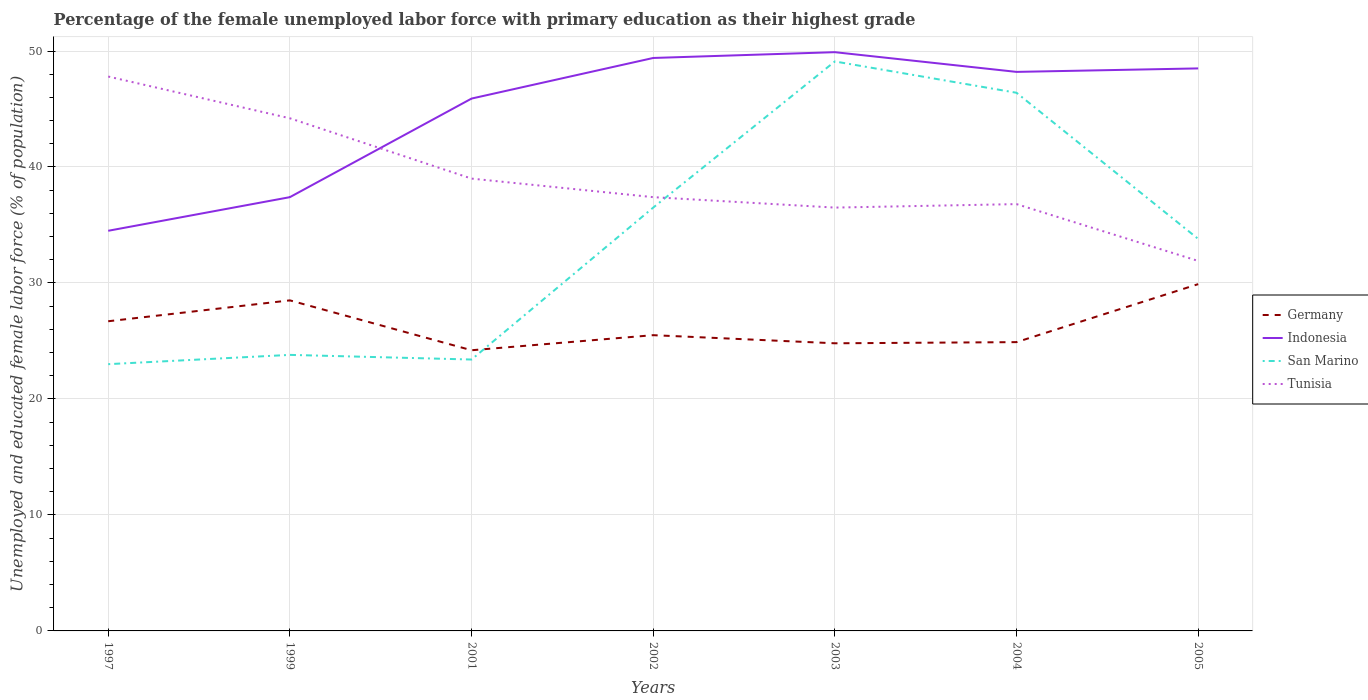How many different coloured lines are there?
Give a very brief answer. 4. Across all years, what is the maximum percentage of the unemployed female labor force with primary education in Indonesia?
Offer a terse response. 34.5. What is the total percentage of the unemployed female labor force with primary education in San Marino in the graph?
Offer a very short reply. -25.3. What is the difference between the highest and the second highest percentage of the unemployed female labor force with primary education in San Marino?
Your response must be concise. 26.1. What is the difference between the highest and the lowest percentage of the unemployed female labor force with primary education in Germany?
Offer a very short reply. 3. Is the percentage of the unemployed female labor force with primary education in Indonesia strictly greater than the percentage of the unemployed female labor force with primary education in Tunisia over the years?
Give a very brief answer. No. Does the graph contain any zero values?
Keep it short and to the point. No. Does the graph contain grids?
Keep it short and to the point. Yes. How many legend labels are there?
Ensure brevity in your answer.  4. How are the legend labels stacked?
Offer a terse response. Vertical. What is the title of the graph?
Offer a terse response. Percentage of the female unemployed labor force with primary education as their highest grade. Does "Niger" appear as one of the legend labels in the graph?
Provide a succinct answer. No. What is the label or title of the X-axis?
Make the answer very short. Years. What is the label or title of the Y-axis?
Your answer should be very brief. Unemployed and educated female labor force (% of population). What is the Unemployed and educated female labor force (% of population) of Germany in 1997?
Keep it short and to the point. 26.7. What is the Unemployed and educated female labor force (% of population) of Indonesia in 1997?
Ensure brevity in your answer.  34.5. What is the Unemployed and educated female labor force (% of population) of San Marino in 1997?
Your answer should be compact. 23. What is the Unemployed and educated female labor force (% of population) of Tunisia in 1997?
Provide a succinct answer. 47.8. What is the Unemployed and educated female labor force (% of population) of Indonesia in 1999?
Provide a short and direct response. 37.4. What is the Unemployed and educated female labor force (% of population) in San Marino in 1999?
Offer a terse response. 23.8. What is the Unemployed and educated female labor force (% of population) in Tunisia in 1999?
Your answer should be very brief. 44.2. What is the Unemployed and educated female labor force (% of population) in Germany in 2001?
Provide a short and direct response. 24.2. What is the Unemployed and educated female labor force (% of population) in Indonesia in 2001?
Give a very brief answer. 45.9. What is the Unemployed and educated female labor force (% of population) in San Marino in 2001?
Give a very brief answer. 23.4. What is the Unemployed and educated female labor force (% of population) of Indonesia in 2002?
Ensure brevity in your answer.  49.4. What is the Unemployed and educated female labor force (% of population) of San Marino in 2002?
Offer a terse response. 36.5. What is the Unemployed and educated female labor force (% of population) in Tunisia in 2002?
Provide a short and direct response. 37.4. What is the Unemployed and educated female labor force (% of population) of Germany in 2003?
Provide a succinct answer. 24.8. What is the Unemployed and educated female labor force (% of population) in Indonesia in 2003?
Offer a terse response. 49.9. What is the Unemployed and educated female labor force (% of population) of San Marino in 2003?
Your response must be concise. 49.1. What is the Unemployed and educated female labor force (% of population) in Tunisia in 2003?
Your response must be concise. 36.5. What is the Unemployed and educated female labor force (% of population) in Germany in 2004?
Provide a short and direct response. 24.9. What is the Unemployed and educated female labor force (% of population) in Indonesia in 2004?
Provide a succinct answer. 48.2. What is the Unemployed and educated female labor force (% of population) in San Marino in 2004?
Keep it short and to the point. 46.4. What is the Unemployed and educated female labor force (% of population) of Tunisia in 2004?
Ensure brevity in your answer.  36.8. What is the Unemployed and educated female labor force (% of population) in Germany in 2005?
Keep it short and to the point. 29.9. What is the Unemployed and educated female labor force (% of population) of Indonesia in 2005?
Offer a very short reply. 48.5. What is the Unemployed and educated female labor force (% of population) in San Marino in 2005?
Provide a succinct answer. 33.8. What is the Unemployed and educated female labor force (% of population) of Tunisia in 2005?
Your response must be concise. 31.9. Across all years, what is the maximum Unemployed and educated female labor force (% of population) in Germany?
Ensure brevity in your answer.  29.9. Across all years, what is the maximum Unemployed and educated female labor force (% of population) in Indonesia?
Your answer should be very brief. 49.9. Across all years, what is the maximum Unemployed and educated female labor force (% of population) of San Marino?
Give a very brief answer. 49.1. Across all years, what is the maximum Unemployed and educated female labor force (% of population) of Tunisia?
Ensure brevity in your answer.  47.8. Across all years, what is the minimum Unemployed and educated female labor force (% of population) in Germany?
Make the answer very short. 24.2. Across all years, what is the minimum Unemployed and educated female labor force (% of population) in Indonesia?
Ensure brevity in your answer.  34.5. Across all years, what is the minimum Unemployed and educated female labor force (% of population) of San Marino?
Provide a short and direct response. 23. Across all years, what is the minimum Unemployed and educated female labor force (% of population) of Tunisia?
Provide a succinct answer. 31.9. What is the total Unemployed and educated female labor force (% of population) in Germany in the graph?
Ensure brevity in your answer.  184.5. What is the total Unemployed and educated female labor force (% of population) of Indonesia in the graph?
Your response must be concise. 313.8. What is the total Unemployed and educated female labor force (% of population) in San Marino in the graph?
Your answer should be compact. 236. What is the total Unemployed and educated female labor force (% of population) in Tunisia in the graph?
Ensure brevity in your answer.  273.6. What is the difference between the Unemployed and educated female labor force (% of population) of San Marino in 1997 and that in 1999?
Offer a very short reply. -0.8. What is the difference between the Unemployed and educated female labor force (% of population) in Germany in 1997 and that in 2001?
Your answer should be very brief. 2.5. What is the difference between the Unemployed and educated female labor force (% of population) in Indonesia in 1997 and that in 2001?
Keep it short and to the point. -11.4. What is the difference between the Unemployed and educated female labor force (% of population) of San Marino in 1997 and that in 2001?
Make the answer very short. -0.4. What is the difference between the Unemployed and educated female labor force (% of population) in Tunisia in 1997 and that in 2001?
Your answer should be very brief. 8.8. What is the difference between the Unemployed and educated female labor force (% of population) in Germany in 1997 and that in 2002?
Provide a short and direct response. 1.2. What is the difference between the Unemployed and educated female labor force (% of population) of Indonesia in 1997 and that in 2002?
Your response must be concise. -14.9. What is the difference between the Unemployed and educated female labor force (% of population) of San Marino in 1997 and that in 2002?
Give a very brief answer. -13.5. What is the difference between the Unemployed and educated female labor force (% of population) in Tunisia in 1997 and that in 2002?
Make the answer very short. 10.4. What is the difference between the Unemployed and educated female labor force (% of population) of Indonesia in 1997 and that in 2003?
Your answer should be compact. -15.4. What is the difference between the Unemployed and educated female labor force (% of population) in San Marino in 1997 and that in 2003?
Make the answer very short. -26.1. What is the difference between the Unemployed and educated female labor force (% of population) of Tunisia in 1997 and that in 2003?
Keep it short and to the point. 11.3. What is the difference between the Unemployed and educated female labor force (% of population) of Germany in 1997 and that in 2004?
Provide a succinct answer. 1.8. What is the difference between the Unemployed and educated female labor force (% of population) in Indonesia in 1997 and that in 2004?
Provide a succinct answer. -13.7. What is the difference between the Unemployed and educated female labor force (% of population) in San Marino in 1997 and that in 2004?
Your answer should be compact. -23.4. What is the difference between the Unemployed and educated female labor force (% of population) of San Marino in 1997 and that in 2005?
Provide a succinct answer. -10.8. What is the difference between the Unemployed and educated female labor force (% of population) in Tunisia in 1997 and that in 2005?
Your answer should be compact. 15.9. What is the difference between the Unemployed and educated female labor force (% of population) of Indonesia in 1999 and that in 2001?
Keep it short and to the point. -8.5. What is the difference between the Unemployed and educated female labor force (% of population) of Tunisia in 1999 and that in 2001?
Offer a very short reply. 5.2. What is the difference between the Unemployed and educated female labor force (% of population) in San Marino in 1999 and that in 2002?
Provide a short and direct response. -12.7. What is the difference between the Unemployed and educated female labor force (% of population) of Germany in 1999 and that in 2003?
Your answer should be very brief. 3.7. What is the difference between the Unemployed and educated female labor force (% of population) in Indonesia in 1999 and that in 2003?
Provide a succinct answer. -12.5. What is the difference between the Unemployed and educated female labor force (% of population) in San Marino in 1999 and that in 2003?
Your answer should be very brief. -25.3. What is the difference between the Unemployed and educated female labor force (% of population) of Tunisia in 1999 and that in 2003?
Keep it short and to the point. 7.7. What is the difference between the Unemployed and educated female labor force (% of population) in Germany in 1999 and that in 2004?
Make the answer very short. 3.6. What is the difference between the Unemployed and educated female labor force (% of population) of San Marino in 1999 and that in 2004?
Offer a terse response. -22.6. What is the difference between the Unemployed and educated female labor force (% of population) of Germany in 2001 and that in 2002?
Provide a succinct answer. -1.3. What is the difference between the Unemployed and educated female labor force (% of population) in Indonesia in 2001 and that in 2002?
Keep it short and to the point. -3.5. What is the difference between the Unemployed and educated female labor force (% of population) of San Marino in 2001 and that in 2002?
Give a very brief answer. -13.1. What is the difference between the Unemployed and educated female labor force (% of population) of Indonesia in 2001 and that in 2003?
Your answer should be very brief. -4. What is the difference between the Unemployed and educated female labor force (% of population) in San Marino in 2001 and that in 2003?
Offer a terse response. -25.7. What is the difference between the Unemployed and educated female labor force (% of population) in Tunisia in 2001 and that in 2003?
Make the answer very short. 2.5. What is the difference between the Unemployed and educated female labor force (% of population) of Germany in 2001 and that in 2004?
Your answer should be compact. -0.7. What is the difference between the Unemployed and educated female labor force (% of population) in Germany in 2001 and that in 2005?
Your answer should be compact. -5.7. What is the difference between the Unemployed and educated female labor force (% of population) in San Marino in 2002 and that in 2003?
Ensure brevity in your answer.  -12.6. What is the difference between the Unemployed and educated female labor force (% of population) of Germany in 2002 and that in 2004?
Your answer should be compact. 0.6. What is the difference between the Unemployed and educated female labor force (% of population) of San Marino in 2002 and that in 2004?
Ensure brevity in your answer.  -9.9. What is the difference between the Unemployed and educated female labor force (% of population) of Tunisia in 2002 and that in 2004?
Your answer should be very brief. 0.6. What is the difference between the Unemployed and educated female labor force (% of population) in Germany in 2002 and that in 2005?
Provide a succinct answer. -4.4. What is the difference between the Unemployed and educated female labor force (% of population) of Indonesia in 2002 and that in 2005?
Provide a succinct answer. 0.9. What is the difference between the Unemployed and educated female labor force (% of population) in Germany in 2003 and that in 2004?
Your answer should be compact. -0.1. What is the difference between the Unemployed and educated female labor force (% of population) of Tunisia in 2003 and that in 2004?
Give a very brief answer. -0.3. What is the difference between the Unemployed and educated female labor force (% of population) in Tunisia in 2003 and that in 2005?
Offer a very short reply. 4.6. What is the difference between the Unemployed and educated female labor force (% of population) in Germany in 2004 and that in 2005?
Ensure brevity in your answer.  -5. What is the difference between the Unemployed and educated female labor force (% of population) of Tunisia in 2004 and that in 2005?
Your response must be concise. 4.9. What is the difference between the Unemployed and educated female labor force (% of population) in Germany in 1997 and the Unemployed and educated female labor force (% of population) in Indonesia in 1999?
Your answer should be compact. -10.7. What is the difference between the Unemployed and educated female labor force (% of population) of Germany in 1997 and the Unemployed and educated female labor force (% of population) of Tunisia in 1999?
Give a very brief answer. -17.5. What is the difference between the Unemployed and educated female labor force (% of population) in Indonesia in 1997 and the Unemployed and educated female labor force (% of population) in San Marino in 1999?
Offer a very short reply. 10.7. What is the difference between the Unemployed and educated female labor force (% of population) in San Marino in 1997 and the Unemployed and educated female labor force (% of population) in Tunisia in 1999?
Your response must be concise. -21.2. What is the difference between the Unemployed and educated female labor force (% of population) in Germany in 1997 and the Unemployed and educated female labor force (% of population) in Indonesia in 2001?
Your answer should be compact. -19.2. What is the difference between the Unemployed and educated female labor force (% of population) in Germany in 1997 and the Unemployed and educated female labor force (% of population) in San Marino in 2001?
Your answer should be compact. 3.3. What is the difference between the Unemployed and educated female labor force (% of population) of Germany in 1997 and the Unemployed and educated female labor force (% of population) of Tunisia in 2001?
Give a very brief answer. -12.3. What is the difference between the Unemployed and educated female labor force (% of population) in Indonesia in 1997 and the Unemployed and educated female labor force (% of population) in Tunisia in 2001?
Provide a succinct answer. -4.5. What is the difference between the Unemployed and educated female labor force (% of population) of Germany in 1997 and the Unemployed and educated female labor force (% of population) of Indonesia in 2002?
Offer a very short reply. -22.7. What is the difference between the Unemployed and educated female labor force (% of population) of San Marino in 1997 and the Unemployed and educated female labor force (% of population) of Tunisia in 2002?
Provide a short and direct response. -14.4. What is the difference between the Unemployed and educated female labor force (% of population) of Germany in 1997 and the Unemployed and educated female labor force (% of population) of Indonesia in 2003?
Provide a succinct answer. -23.2. What is the difference between the Unemployed and educated female labor force (% of population) in Germany in 1997 and the Unemployed and educated female labor force (% of population) in San Marino in 2003?
Provide a short and direct response. -22.4. What is the difference between the Unemployed and educated female labor force (% of population) of Indonesia in 1997 and the Unemployed and educated female labor force (% of population) of San Marino in 2003?
Offer a very short reply. -14.6. What is the difference between the Unemployed and educated female labor force (% of population) in Germany in 1997 and the Unemployed and educated female labor force (% of population) in Indonesia in 2004?
Your answer should be compact. -21.5. What is the difference between the Unemployed and educated female labor force (% of population) in Germany in 1997 and the Unemployed and educated female labor force (% of population) in San Marino in 2004?
Your response must be concise. -19.7. What is the difference between the Unemployed and educated female labor force (% of population) of Germany in 1997 and the Unemployed and educated female labor force (% of population) of Tunisia in 2004?
Make the answer very short. -10.1. What is the difference between the Unemployed and educated female labor force (% of population) in Indonesia in 1997 and the Unemployed and educated female labor force (% of population) in San Marino in 2004?
Your answer should be very brief. -11.9. What is the difference between the Unemployed and educated female labor force (% of population) of Germany in 1997 and the Unemployed and educated female labor force (% of population) of Indonesia in 2005?
Your response must be concise. -21.8. What is the difference between the Unemployed and educated female labor force (% of population) in Germany in 1997 and the Unemployed and educated female labor force (% of population) in San Marino in 2005?
Your answer should be very brief. -7.1. What is the difference between the Unemployed and educated female labor force (% of population) in Germany in 1999 and the Unemployed and educated female labor force (% of population) in Indonesia in 2001?
Offer a terse response. -17.4. What is the difference between the Unemployed and educated female labor force (% of population) in Germany in 1999 and the Unemployed and educated female labor force (% of population) in Tunisia in 2001?
Offer a terse response. -10.5. What is the difference between the Unemployed and educated female labor force (% of population) in San Marino in 1999 and the Unemployed and educated female labor force (% of population) in Tunisia in 2001?
Your answer should be compact. -15.2. What is the difference between the Unemployed and educated female labor force (% of population) in Germany in 1999 and the Unemployed and educated female labor force (% of population) in Indonesia in 2002?
Keep it short and to the point. -20.9. What is the difference between the Unemployed and educated female labor force (% of population) of Germany in 1999 and the Unemployed and educated female labor force (% of population) of San Marino in 2002?
Offer a very short reply. -8. What is the difference between the Unemployed and educated female labor force (% of population) in Germany in 1999 and the Unemployed and educated female labor force (% of population) in Indonesia in 2003?
Your response must be concise. -21.4. What is the difference between the Unemployed and educated female labor force (% of population) of Germany in 1999 and the Unemployed and educated female labor force (% of population) of San Marino in 2003?
Provide a succinct answer. -20.6. What is the difference between the Unemployed and educated female labor force (% of population) in Indonesia in 1999 and the Unemployed and educated female labor force (% of population) in San Marino in 2003?
Provide a succinct answer. -11.7. What is the difference between the Unemployed and educated female labor force (% of population) of Germany in 1999 and the Unemployed and educated female labor force (% of population) of Indonesia in 2004?
Give a very brief answer. -19.7. What is the difference between the Unemployed and educated female labor force (% of population) in Germany in 1999 and the Unemployed and educated female labor force (% of population) in San Marino in 2004?
Give a very brief answer. -17.9. What is the difference between the Unemployed and educated female labor force (% of population) of Indonesia in 1999 and the Unemployed and educated female labor force (% of population) of Tunisia in 2004?
Keep it short and to the point. 0.6. What is the difference between the Unemployed and educated female labor force (% of population) in Germany in 2001 and the Unemployed and educated female labor force (% of population) in Indonesia in 2002?
Provide a succinct answer. -25.2. What is the difference between the Unemployed and educated female labor force (% of population) of Germany in 2001 and the Unemployed and educated female labor force (% of population) of San Marino in 2002?
Your answer should be compact. -12.3. What is the difference between the Unemployed and educated female labor force (% of population) in Indonesia in 2001 and the Unemployed and educated female labor force (% of population) in San Marino in 2002?
Offer a very short reply. 9.4. What is the difference between the Unemployed and educated female labor force (% of population) in Indonesia in 2001 and the Unemployed and educated female labor force (% of population) in Tunisia in 2002?
Provide a succinct answer. 8.5. What is the difference between the Unemployed and educated female labor force (% of population) of San Marino in 2001 and the Unemployed and educated female labor force (% of population) of Tunisia in 2002?
Offer a very short reply. -14. What is the difference between the Unemployed and educated female labor force (% of population) of Germany in 2001 and the Unemployed and educated female labor force (% of population) of Indonesia in 2003?
Your answer should be very brief. -25.7. What is the difference between the Unemployed and educated female labor force (% of population) of Germany in 2001 and the Unemployed and educated female labor force (% of population) of San Marino in 2003?
Make the answer very short. -24.9. What is the difference between the Unemployed and educated female labor force (% of population) of Indonesia in 2001 and the Unemployed and educated female labor force (% of population) of Tunisia in 2003?
Offer a very short reply. 9.4. What is the difference between the Unemployed and educated female labor force (% of population) in Germany in 2001 and the Unemployed and educated female labor force (% of population) in San Marino in 2004?
Give a very brief answer. -22.2. What is the difference between the Unemployed and educated female labor force (% of population) in Indonesia in 2001 and the Unemployed and educated female labor force (% of population) in San Marino in 2004?
Offer a very short reply. -0.5. What is the difference between the Unemployed and educated female labor force (% of population) of Germany in 2001 and the Unemployed and educated female labor force (% of population) of Indonesia in 2005?
Give a very brief answer. -24.3. What is the difference between the Unemployed and educated female labor force (% of population) of Germany in 2001 and the Unemployed and educated female labor force (% of population) of San Marino in 2005?
Your response must be concise. -9.6. What is the difference between the Unemployed and educated female labor force (% of population) of Germany in 2001 and the Unemployed and educated female labor force (% of population) of Tunisia in 2005?
Make the answer very short. -7.7. What is the difference between the Unemployed and educated female labor force (% of population) in Indonesia in 2001 and the Unemployed and educated female labor force (% of population) in Tunisia in 2005?
Offer a terse response. 14. What is the difference between the Unemployed and educated female labor force (% of population) of Germany in 2002 and the Unemployed and educated female labor force (% of population) of Indonesia in 2003?
Make the answer very short. -24.4. What is the difference between the Unemployed and educated female labor force (% of population) in Germany in 2002 and the Unemployed and educated female labor force (% of population) in San Marino in 2003?
Offer a very short reply. -23.6. What is the difference between the Unemployed and educated female labor force (% of population) of Indonesia in 2002 and the Unemployed and educated female labor force (% of population) of San Marino in 2003?
Make the answer very short. 0.3. What is the difference between the Unemployed and educated female labor force (% of population) of Indonesia in 2002 and the Unemployed and educated female labor force (% of population) of Tunisia in 2003?
Make the answer very short. 12.9. What is the difference between the Unemployed and educated female labor force (% of population) of San Marino in 2002 and the Unemployed and educated female labor force (% of population) of Tunisia in 2003?
Provide a short and direct response. 0. What is the difference between the Unemployed and educated female labor force (% of population) of Germany in 2002 and the Unemployed and educated female labor force (% of population) of Indonesia in 2004?
Provide a succinct answer. -22.7. What is the difference between the Unemployed and educated female labor force (% of population) of Germany in 2002 and the Unemployed and educated female labor force (% of population) of San Marino in 2004?
Your response must be concise. -20.9. What is the difference between the Unemployed and educated female labor force (% of population) in Germany in 2002 and the Unemployed and educated female labor force (% of population) in Tunisia in 2004?
Your response must be concise. -11.3. What is the difference between the Unemployed and educated female labor force (% of population) of Indonesia in 2002 and the Unemployed and educated female labor force (% of population) of San Marino in 2004?
Offer a terse response. 3. What is the difference between the Unemployed and educated female labor force (% of population) of Germany in 2002 and the Unemployed and educated female labor force (% of population) of San Marino in 2005?
Provide a succinct answer. -8.3. What is the difference between the Unemployed and educated female labor force (% of population) of Indonesia in 2002 and the Unemployed and educated female labor force (% of population) of Tunisia in 2005?
Keep it short and to the point. 17.5. What is the difference between the Unemployed and educated female labor force (% of population) of Germany in 2003 and the Unemployed and educated female labor force (% of population) of Indonesia in 2004?
Make the answer very short. -23.4. What is the difference between the Unemployed and educated female labor force (% of population) in Germany in 2003 and the Unemployed and educated female labor force (% of population) in San Marino in 2004?
Your answer should be compact. -21.6. What is the difference between the Unemployed and educated female labor force (% of population) of Indonesia in 2003 and the Unemployed and educated female labor force (% of population) of San Marino in 2004?
Provide a succinct answer. 3.5. What is the difference between the Unemployed and educated female labor force (% of population) of Indonesia in 2003 and the Unemployed and educated female labor force (% of population) of Tunisia in 2004?
Your answer should be compact. 13.1. What is the difference between the Unemployed and educated female labor force (% of population) of San Marino in 2003 and the Unemployed and educated female labor force (% of population) of Tunisia in 2004?
Ensure brevity in your answer.  12.3. What is the difference between the Unemployed and educated female labor force (% of population) of Germany in 2003 and the Unemployed and educated female labor force (% of population) of Indonesia in 2005?
Give a very brief answer. -23.7. What is the difference between the Unemployed and educated female labor force (% of population) of Germany in 2003 and the Unemployed and educated female labor force (% of population) of Tunisia in 2005?
Offer a terse response. -7.1. What is the difference between the Unemployed and educated female labor force (% of population) in Indonesia in 2003 and the Unemployed and educated female labor force (% of population) in Tunisia in 2005?
Provide a succinct answer. 18. What is the difference between the Unemployed and educated female labor force (% of population) in San Marino in 2003 and the Unemployed and educated female labor force (% of population) in Tunisia in 2005?
Provide a short and direct response. 17.2. What is the difference between the Unemployed and educated female labor force (% of population) in Germany in 2004 and the Unemployed and educated female labor force (% of population) in Indonesia in 2005?
Keep it short and to the point. -23.6. What is the difference between the Unemployed and educated female labor force (% of population) in Germany in 2004 and the Unemployed and educated female labor force (% of population) in San Marino in 2005?
Provide a succinct answer. -8.9. What is the difference between the Unemployed and educated female labor force (% of population) in Indonesia in 2004 and the Unemployed and educated female labor force (% of population) in San Marino in 2005?
Provide a short and direct response. 14.4. What is the difference between the Unemployed and educated female labor force (% of population) of Indonesia in 2004 and the Unemployed and educated female labor force (% of population) of Tunisia in 2005?
Provide a succinct answer. 16.3. What is the difference between the Unemployed and educated female labor force (% of population) of San Marino in 2004 and the Unemployed and educated female labor force (% of population) of Tunisia in 2005?
Offer a terse response. 14.5. What is the average Unemployed and educated female labor force (% of population) of Germany per year?
Your response must be concise. 26.36. What is the average Unemployed and educated female labor force (% of population) of Indonesia per year?
Make the answer very short. 44.83. What is the average Unemployed and educated female labor force (% of population) in San Marino per year?
Keep it short and to the point. 33.71. What is the average Unemployed and educated female labor force (% of population) in Tunisia per year?
Provide a short and direct response. 39.09. In the year 1997, what is the difference between the Unemployed and educated female labor force (% of population) in Germany and Unemployed and educated female labor force (% of population) in San Marino?
Your answer should be compact. 3.7. In the year 1997, what is the difference between the Unemployed and educated female labor force (% of population) in Germany and Unemployed and educated female labor force (% of population) in Tunisia?
Provide a short and direct response. -21.1. In the year 1997, what is the difference between the Unemployed and educated female labor force (% of population) in Indonesia and Unemployed and educated female labor force (% of population) in Tunisia?
Provide a succinct answer. -13.3. In the year 1997, what is the difference between the Unemployed and educated female labor force (% of population) of San Marino and Unemployed and educated female labor force (% of population) of Tunisia?
Make the answer very short. -24.8. In the year 1999, what is the difference between the Unemployed and educated female labor force (% of population) of Germany and Unemployed and educated female labor force (% of population) of San Marino?
Provide a succinct answer. 4.7. In the year 1999, what is the difference between the Unemployed and educated female labor force (% of population) of Germany and Unemployed and educated female labor force (% of population) of Tunisia?
Give a very brief answer. -15.7. In the year 1999, what is the difference between the Unemployed and educated female labor force (% of population) in San Marino and Unemployed and educated female labor force (% of population) in Tunisia?
Ensure brevity in your answer.  -20.4. In the year 2001, what is the difference between the Unemployed and educated female labor force (% of population) of Germany and Unemployed and educated female labor force (% of population) of Indonesia?
Provide a succinct answer. -21.7. In the year 2001, what is the difference between the Unemployed and educated female labor force (% of population) of Germany and Unemployed and educated female labor force (% of population) of Tunisia?
Make the answer very short. -14.8. In the year 2001, what is the difference between the Unemployed and educated female labor force (% of population) in Indonesia and Unemployed and educated female labor force (% of population) in San Marino?
Make the answer very short. 22.5. In the year 2001, what is the difference between the Unemployed and educated female labor force (% of population) of Indonesia and Unemployed and educated female labor force (% of population) of Tunisia?
Offer a terse response. 6.9. In the year 2001, what is the difference between the Unemployed and educated female labor force (% of population) in San Marino and Unemployed and educated female labor force (% of population) in Tunisia?
Offer a very short reply. -15.6. In the year 2002, what is the difference between the Unemployed and educated female labor force (% of population) of Germany and Unemployed and educated female labor force (% of population) of Indonesia?
Provide a short and direct response. -23.9. In the year 2002, what is the difference between the Unemployed and educated female labor force (% of population) of Indonesia and Unemployed and educated female labor force (% of population) of Tunisia?
Offer a very short reply. 12. In the year 2003, what is the difference between the Unemployed and educated female labor force (% of population) of Germany and Unemployed and educated female labor force (% of population) of Indonesia?
Ensure brevity in your answer.  -25.1. In the year 2003, what is the difference between the Unemployed and educated female labor force (% of population) of Germany and Unemployed and educated female labor force (% of population) of San Marino?
Offer a very short reply. -24.3. In the year 2003, what is the difference between the Unemployed and educated female labor force (% of population) in Germany and Unemployed and educated female labor force (% of population) in Tunisia?
Offer a very short reply. -11.7. In the year 2003, what is the difference between the Unemployed and educated female labor force (% of population) in Indonesia and Unemployed and educated female labor force (% of population) in San Marino?
Ensure brevity in your answer.  0.8. In the year 2003, what is the difference between the Unemployed and educated female labor force (% of population) of Indonesia and Unemployed and educated female labor force (% of population) of Tunisia?
Ensure brevity in your answer.  13.4. In the year 2003, what is the difference between the Unemployed and educated female labor force (% of population) of San Marino and Unemployed and educated female labor force (% of population) of Tunisia?
Your answer should be very brief. 12.6. In the year 2004, what is the difference between the Unemployed and educated female labor force (% of population) in Germany and Unemployed and educated female labor force (% of population) in Indonesia?
Your response must be concise. -23.3. In the year 2004, what is the difference between the Unemployed and educated female labor force (% of population) in Germany and Unemployed and educated female labor force (% of population) in San Marino?
Offer a very short reply. -21.5. In the year 2004, what is the difference between the Unemployed and educated female labor force (% of population) of Germany and Unemployed and educated female labor force (% of population) of Tunisia?
Your response must be concise. -11.9. In the year 2004, what is the difference between the Unemployed and educated female labor force (% of population) in San Marino and Unemployed and educated female labor force (% of population) in Tunisia?
Provide a succinct answer. 9.6. In the year 2005, what is the difference between the Unemployed and educated female labor force (% of population) in Germany and Unemployed and educated female labor force (% of population) in Indonesia?
Your answer should be compact. -18.6. In the year 2005, what is the difference between the Unemployed and educated female labor force (% of population) in Germany and Unemployed and educated female labor force (% of population) in San Marino?
Keep it short and to the point. -3.9. In the year 2005, what is the difference between the Unemployed and educated female labor force (% of population) of Germany and Unemployed and educated female labor force (% of population) of Tunisia?
Provide a succinct answer. -2. In the year 2005, what is the difference between the Unemployed and educated female labor force (% of population) in Indonesia and Unemployed and educated female labor force (% of population) in San Marino?
Your answer should be very brief. 14.7. In the year 2005, what is the difference between the Unemployed and educated female labor force (% of population) in Indonesia and Unemployed and educated female labor force (% of population) in Tunisia?
Your answer should be compact. 16.6. In the year 2005, what is the difference between the Unemployed and educated female labor force (% of population) in San Marino and Unemployed and educated female labor force (% of population) in Tunisia?
Give a very brief answer. 1.9. What is the ratio of the Unemployed and educated female labor force (% of population) in Germany in 1997 to that in 1999?
Give a very brief answer. 0.94. What is the ratio of the Unemployed and educated female labor force (% of population) of Indonesia in 1997 to that in 1999?
Give a very brief answer. 0.92. What is the ratio of the Unemployed and educated female labor force (% of population) in San Marino in 1997 to that in 1999?
Give a very brief answer. 0.97. What is the ratio of the Unemployed and educated female labor force (% of population) in Tunisia in 1997 to that in 1999?
Make the answer very short. 1.08. What is the ratio of the Unemployed and educated female labor force (% of population) in Germany in 1997 to that in 2001?
Your response must be concise. 1.1. What is the ratio of the Unemployed and educated female labor force (% of population) of Indonesia in 1997 to that in 2001?
Your answer should be compact. 0.75. What is the ratio of the Unemployed and educated female labor force (% of population) of San Marino in 1997 to that in 2001?
Your answer should be very brief. 0.98. What is the ratio of the Unemployed and educated female labor force (% of population) of Tunisia in 1997 to that in 2001?
Give a very brief answer. 1.23. What is the ratio of the Unemployed and educated female labor force (% of population) of Germany in 1997 to that in 2002?
Your answer should be compact. 1.05. What is the ratio of the Unemployed and educated female labor force (% of population) in Indonesia in 1997 to that in 2002?
Your response must be concise. 0.7. What is the ratio of the Unemployed and educated female labor force (% of population) in San Marino in 1997 to that in 2002?
Offer a terse response. 0.63. What is the ratio of the Unemployed and educated female labor force (% of population) in Tunisia in 1997 to that in 2002?
Provide a short and direct response. 1.28. What is the ratio of the Unemployed and educated female labor force (% of population) in Germany in 1997 to that in 2003?
Provide a succinct answer. 1.08. What is the ratio of the Unemployed and educated female labor force (% of population) in Indonesia in 1997 to that in 2003?
Make the answer very short. 0.69. What is the ratio of the Unemployed and educated female labor force (% of population) in San Marino in 1997 to that in 2003?
Your response must be concise. 0.47. What is the ratio of the Unemployed and educated female labor force (% of population) in Tunisia in 1997 to that in 2003?
Ensure brevity in your answer.  1.31. What is the ratio of the Unemployed and educated female labor force (% of population) in Germany in 1997 to that in 2004?
Your answer should be compact. 1.07. What is the ratio of the Unemployed and educated female labor force (% of population) of Indonesia in 1997 to that in 2004?
Ensure brevity in your answer.  0.72. What is the ratio of the Unemployed and educated female labor force (% of population) in San Marino in 1997 to that in 2004?
Offer a very short reply. 0.5. What is the ratio of the Unemployed and educated female labor force (% of population) in Tunisia in 1997 to that in 2004?
Ensure brevity in your answer.  1.3. What is the ratio of the Unemployed and educated female labor force (% of population) in Germany in 1997 to that in 2005?
Provide a short and direct response. 0.89. What is the ratio of the Unemployed and educated female labor force (% of population) in Indonesia in 1997 to that in 2005?
Provide a succinct answer. 0.71. What is the ratio of the Unemployed and educated female labor force (% of population) of San Marino in 1997 to that in 2005?
Make the answer very short. 0.68. What is the ratio of the Unemployed and educated female labor force (% of population) of Tunisia in 1997 to that in 2005?
Keep it short and to the point. 1.5. What is the ratio of the Unemployed and educated female labor force (% of population) of Germany in 1999 to that in 2001?
Your answer should be very brief. 1.18. What is the ratio of the Unemployed and educated female labor force (% of population) in Indonesia in 1999 to that in 2001?
Provide a succinct answer. 0.81. What is the ratio of the Unemployed and educated female labor force (% of population) of San Marino in 1999 to that in 2001?
Your response must be concise. 1.02. What is the ratio of the Unemployed and educated female labor force (% of population) of Tunisia in 1999 to that in 2001?
Provide a succinct answer. 1.13. What is the ratio of the Unemployed and educated female labor force (% of population) in Germany in 1999 to that in 2002?
Keep it short and to the point. 1.12. What is the ratio of the Unemployed and educated female labor force (% of population) of Indonesia in 1999 to that in 2002?
Offer a very short reply. 0.76. What is the ratio of the Unemployed and educated female labor force (% of population) in San Marino in 1999 to that in 2002?
Offer a very short reply. 0.65. What is the ratio of the Unemployed and educated female labor force (% of population) in Tunisia in 1999 to that in 2002?
Your response must be concise. 1.18. What is the ratio of the Unemployed and educated female labor force (% of population) in Germany in 1999 to that in 2003?
Your answer should be compact. 1.15. What is the ratio of the Unemployed and educated female labor force (% of population) in Indonesia in 1999 to that in 2003?
Provide a succinct answer. 0.75. What is the ratio of the Unemployed and educated female labor force (% of population) in San Marino in 1999 to that in 2003?
Offer a terse response. 0.48. What is the ratio of the Unemployed and educated female labor force (% of population) of Tunisia in 1999 to that in 2003?
Keep it short and to the point. 1.21. What is the ratio of the Unemployed and educated female labor force (% of population) in Germany in 1999 to that in 2004?
Offer a terse response. 1.14. What is the ratio of the Unemployed and educated female labor force (% of population) in Indonesia in 1999 to that in 2004?
Provide a succinct answer. 0.78. What is the ratio of the Unemployed and educated female labor force (% of population) in San Marino in 1999 to that in 2004?
Your response must be concise. 0.51. What is the ratio of the Unemployed and educated female labor force (% of population) in Tunisia in 1999 to that in 2004?
Your answer should be very brief. 1.2. What is the ratio of the Unemployed and educated female labor force (% of population) in Germany in 1999 to that in 2005?
Ensure brevity in your answer.  0.95. What is the ratio of the Unemployed and educated female labor force (% of population) of Indonesia in 1999 to that in 2005?
Your response must be concise. 0.77. What is the ratio of the Unemployed and educated female labor force (% of population) of San Marino in 1999 to that in 2005?
Ensure brevity in your answer.  0.7. What is the ratio of the Unemployed and educated female labor force (% of population) of Tunisia in 1999 to that in 2005?
Ensure brevity in your answer.  1.39. What is the ratio of the Unemployed and educated female labor force (% of population) in Germany in 2001 to that in 2002?
Give a very brief answer. 0.95. What is the ratio of the Unemployed and educated female labor force (% of population) in Indonesia in 2001 to that in 2002?
Make the answer very short. 0.93. What is the ratio of the Unemployed and educated female labor force (% of population) of San Marino in 2001 to that in 2002?
Make the answer very short. 0.64. What is the ratio of the Unemployed and educated female labor force (% of population) in Tunisia in 2001 to that in 2002?
Offer a very short reply. 1.04. What is the ratio of the Unemployed and educated female labor force (% of population) in Germany in 2001 to that in 2003?
Your response must be concise. 0.98. What is the ratio of the Unemployed and educated female labor force (% of population) of Indonesia in 2001 to that in 2003?
Keep it short and to the point. 0.92. What is the ratio of the Unemployed and educated female labor force (% of population) in San Marino in 2001 to that in 2003?
Keep it short and to the point. 0.48. What is the ratio of the Unemployed and educated female labor force (% of population) in Tunisia in 2001 to that in 2003?
Offer a very short reply. 1.07. What is the ratio of the Unemployed and educated female labor force (% of population) of Germany in 2001 to that in 2004?
Give a very brief answer. 0.97. What is the ratio of the Unemployed and educated female labor force (% of population) of Indonesia in 2001 to that in 2004?
Give a very brief answer. 0.95. What is the ratio of the Unemployed and educated female labor force (% of population) in San Marino in 2001 to that in 2004?
Your answer should be very brief. 0.5. What is the ratio of the Unemployed and educated female labor force (% of population) in Tunisia in 2001 to that in 2004?
Give a very brief answer. 1.06. What is the ratio of the Unemployed and educated female labor force (% of population) of Germany in 2001 to that in 2005?
Ensure brevity in your answer.  0.81. What is the ratio of the Unemployed and educated female labor force (% of population) of Indonesia in 2001 to that in 2005?
Ensure brevity in your answer.  0.95. What is the ratio of the Unemployed and educated female labor force (% of population) of San Marino in 2001 to that in 2005?
Your answer should be compact. 0.69. What is the ratio of the Unemployed and educated female labor force (% of population) of Tunisia in 2001 to that in 2005?
Provide a succinct answer. 1.22. What is the ratio of the Unemployed and educated female labor force (% of population) of Germany in 2002 to that in 2003?
Provide a succinct answer. 1.03. What is the ratio of the Unemployed and educated female labor force (% of population) in Indonesia in 2002 to that in 2003?
Your answer should be compact. 0.99. What is the ratio of the Unemployed and educated female labor force (% of population) of San Marino in 2002 to that in 2003?
Give a very brief answer. 0.74. What is the ratio of the Unemployed and educated female labor force (% of population) in Tunisia in 2002 to that in 2003?
Ensure brevity in your answer.  1.02. What is the ratio of the Unemployed and educated female labor force (% of population) of Germany in 2002 to that in 2004?
Offer a terse response. 1.02. What is the ratio of the Unemployed and educated female labor force (% of population) in Indonesia in 2002 to that in 2004?
Make the answer very short. 1.02. What is the ratio of the Unemployed and educated female labor force (% of population) of San Marino in 2002 to that in 2004?
Your response must be concise. 0.79. What is the ratio of the Unemployed and educated female labor force (% of population) of Tunisia in 2002 to that in 2004?
Your answer should be very brief. 1.02. What is the ratio of the Unemployed and educated female labor force (% of population) of Germany in 2002 to that in 2005?
Offer a very short reply. 0.85. What is the ratio of the Unemployed and educated female labor force (% of population) in Indonesia in 2002 to that in 2005?
Provide a succinct answer. 1.02. What is the ratio of the Unemployed and educated female labor force (% of population) of San Marino in 2002 to that in 2005?
Offer a very short reply. 1.08. What is the ratio of the Unemployed and educated female labor force (% of population) in Tunisia in 2002 to that in 2005?
Offer a terse response. 1.17. What is the ratio of the Unemployed and educated female labor force (% of population) in Indonesia in 2003 to that in 2004?
Your response must be concise. 1.04. What is the ratio of the Unemployed and educated female labor force (% of population) of San Marino in 2003 to that in 2004?
Offer a terse response. 1.06. What is the ratio of the Unemployed and educated female labor force (% of population) in Germany in 2003 to that in 2005?
Provide a short and direct response. 0.83. What is the ratio of the Unemployed and educated female labor force (% of population) in Indonesia in 2003 to that in 2005?
Make the answer very short. 1.03. What is the ratio of the Unemployed and educated female labor force (% of population) of San Marino in 2003 to that in 2005?
Keep it short and to the point. 1.45. What is the ratio of the Unemployed and educated female labor force (% of population) in Tunisia in 2003 to that in 2005?
Your response must be concise. 1.14. What is the ratio of the Unemployed and educated female labor force (% of population) in Germany in 2004 to that in 2005?
Provide a short and direct response. 0.83. What is the ratio of the Unemployed and educated female labor force (% of population) in San Marino in 2004 to that in 2005?
Your answer should be very brief. 1.37. What is the ratio of the Unemployed and educated female labor force (% of population) in Tunisia in 2004 to that in 2005?
Your answer should be very brief. 1.15. What is the difference between the highest and the second highest Unemployed and educated female labor force (% of population) of Germany?
Offer a terse response. 1.4. What is the difference between the highest and the second highest Unemployed and educated female labor force (% of population) in Indonesia?
Ensure brevity in your answer.  0.5. What is the difference between the highest and the second highest Unemployed and educated female labor force (% of population) of Tunisia?
Provide a short and direct response. 3.6. What is the difference between the highest and the lowest Unemployed and educated female labor force (% of population) of Germany?
Make the answer very short. 5.7. What is the difference between the highest and the lowest Unemployed and educated female labor force (% of population) of San Marino?
Your answer should be compact. 26.1. 